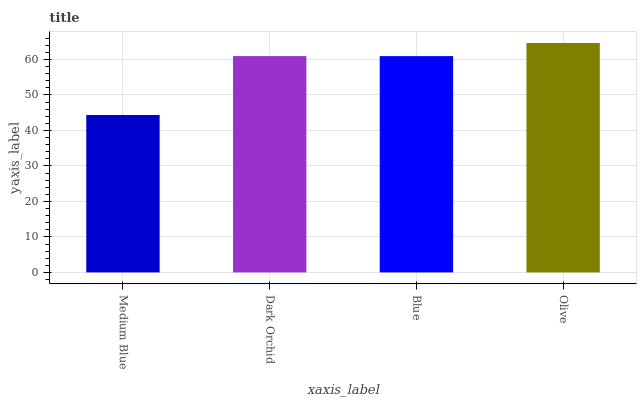Is Medium Blue the minimum?
Answer yes or no. Yes. Is Olive the maximum?
Answer yes or no. Yes. Is Dark Orchid the minimum?
Answer yes or no. No. Is Dark Orchid the maximum?
Answer yes or no. No. Is Dark Orchid greater than Medium Blue?
Answer yes or no. Yes. Is Medium Blue less than Dark Orchid?
Answer yes or no. Yes. Is Medium Blue greater than Dark Orchid?
Answer yes or no. No. Is Dark Orchid less than Medium Blue?
Answer yes or no. No. Is Dark Orchid the high median?
Answer yes or no. Yes. Is Blue the low median?
Answer yes or no. Yes. Is Medium Blue the high median?
Answer yes or no. No. Is Medium Blue the low median?
Answer yes or no. No. 